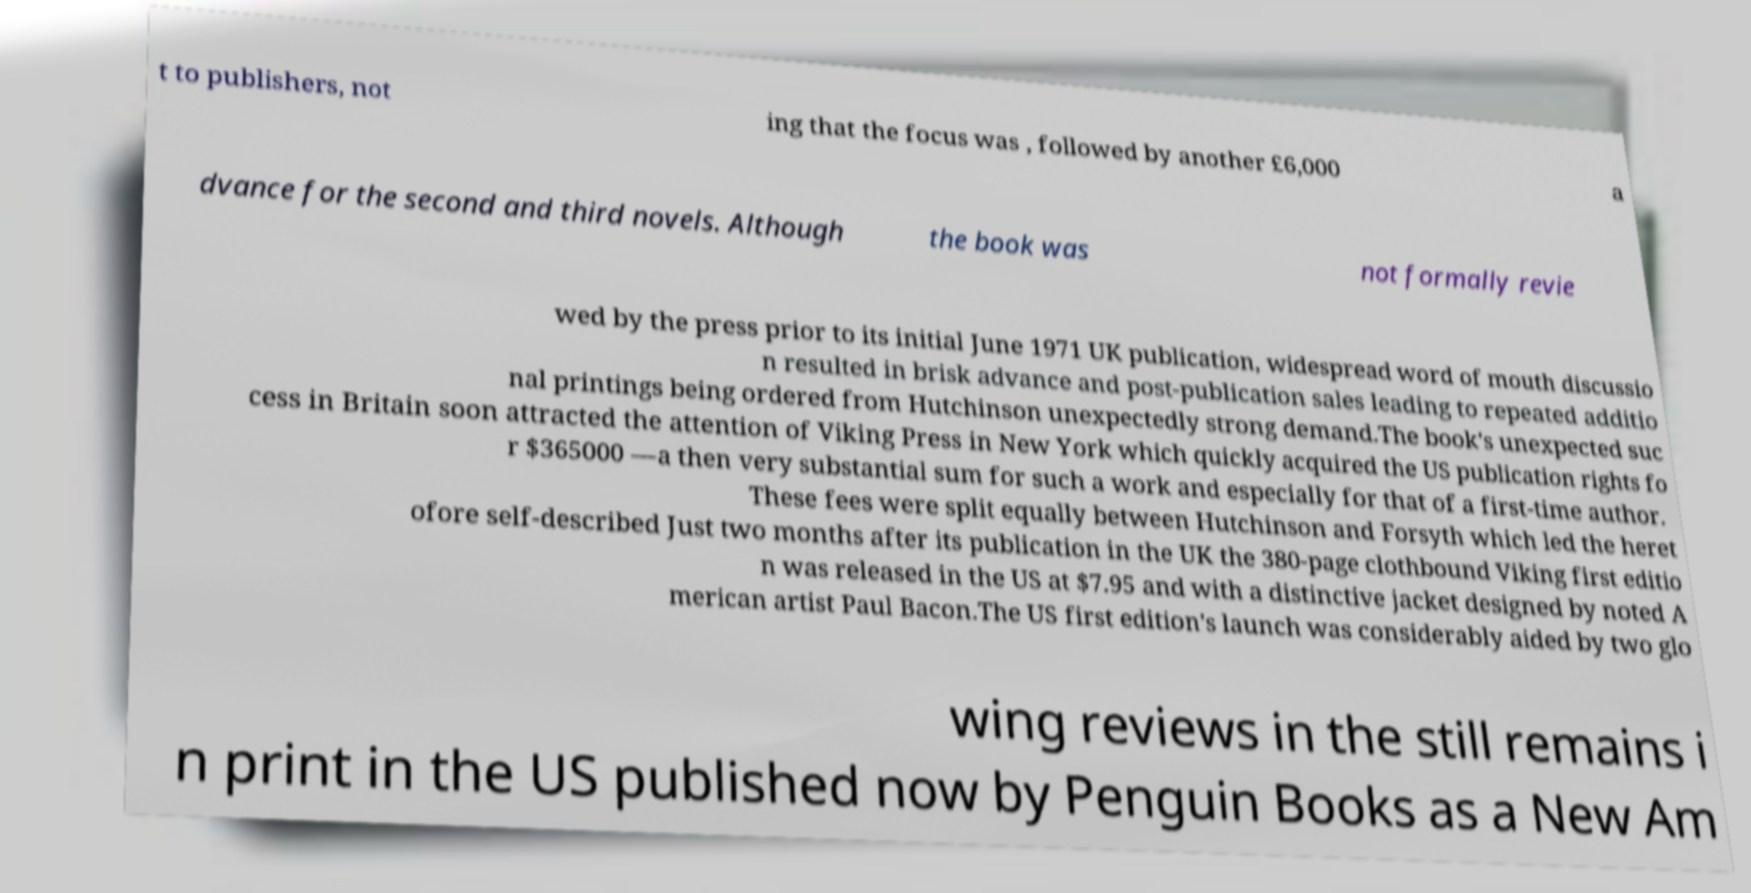Please read and relay the text visible in this image. What does it say? t to publishers, not ing that the focus was , followed by another £6,000 a dvance for the second and third novels. Although the book was not formally revie wed by the press prior to its initial June 1971 UK publication, widespread word of mouth discussio n resulted in brisk advance and post-publication sales leading to repeated additio nal printings being ordered from Hutchinson unexpectedly strong demand.The book's unexpected suc cess in Britain soon attracted the attention of Viking Press in New York which quickly acquired the US publication rights fo r $365000 —a then very substantial sum for such a work and especially for that of a first-time author. These fees were split equally between Hutchinson and Forsyth which led the heret ofore self-described Just two months after its publication in the UK the 380-page clothbound Viking first editio n was released in the US at $7.95 and with a distinctive jacket designed by noted A merican artist Paul Bacon.The US first edition's launch was considerably aided by two glo wing reviews in the still remains i n print in the US published now by Penguin Books as a New Am 